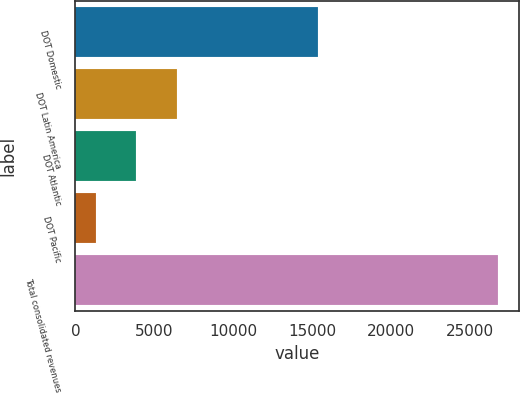Convert chart. <chart><loc_0><loc_0><loc_500><loc_500><bar_chart><fcel>DOT Domestic<fcel>DOT Latin America<fcel>DOT Atlantic<fcel>DOT Pacific<fcel>Total consolidated revenues<nl><fcel>15376<fcel>6407<fcel>3865<fcel>1323<fcel>26743<nl></chart> 